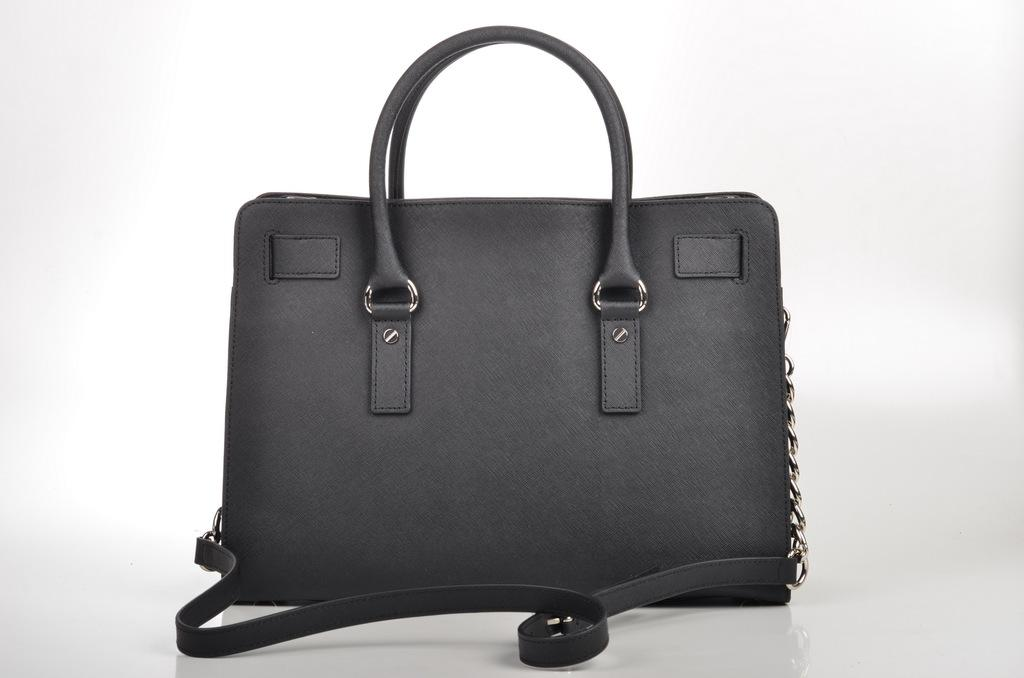What type of item is the main subject of the image? There is a beautifully designed bag in the image. Can you describe any additional features of the bag? There is a chain attached to the bag on the right side. How many snakes are slithering around the bag in the image? There are no snakes present in the image; it only features a beautifully designed bag with a chain attached to it. 